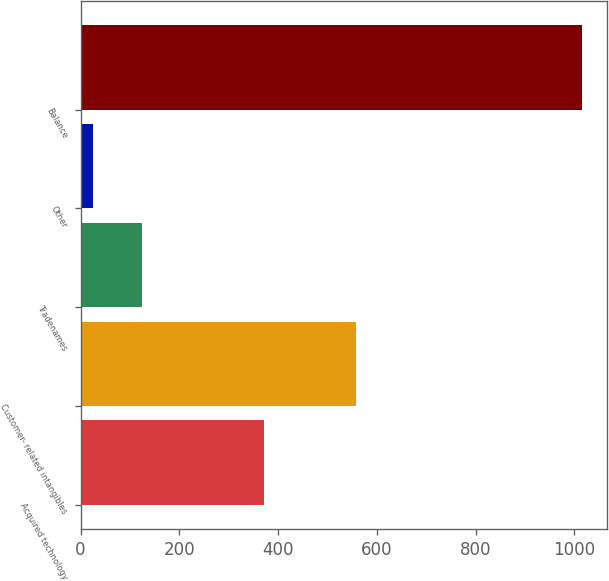Convert chart. <chart><loc_0><loc_0><loc_500><loc_500><bar_chart><fcel>Acquired technology<fcel>Customer- related intangibles<fcel>Tradenames<fcel>Other<fcel>Balance<nl><fcel>372<fcel>557<fcel>125<fcel>26<fcel>1016<nl></chart> 